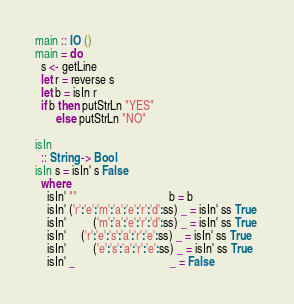Convert code to text. <code><loc_0><loc_0><loc_500><loc_500><_Haskell_>main :: IO ()
main = do
  s <- getLine
  let r = reverse s
  let b = isIn r
  if b then putStrLn "YES"
       else putStrLn "NO"

isIn
  :: String -> Bool
isIn s = isIn' s False
  where
    isIn' ""                               b = b 
    isIn' ('r':'e':'m':'a':'e':'r':'d':ss) _ = isIn' ss True 
    isIn'         ('m':'a':'e':'r':'d':ss) _ = isIn' ss True 
    isIn'     ('r':'e':'s':'a':'r':'e':ss) _ = isIn' ss True
    isIn'         ('e':'s':'a':'r':'e':ss) _ = isIn' ss True
    isIn' _                                _ = False</code> 